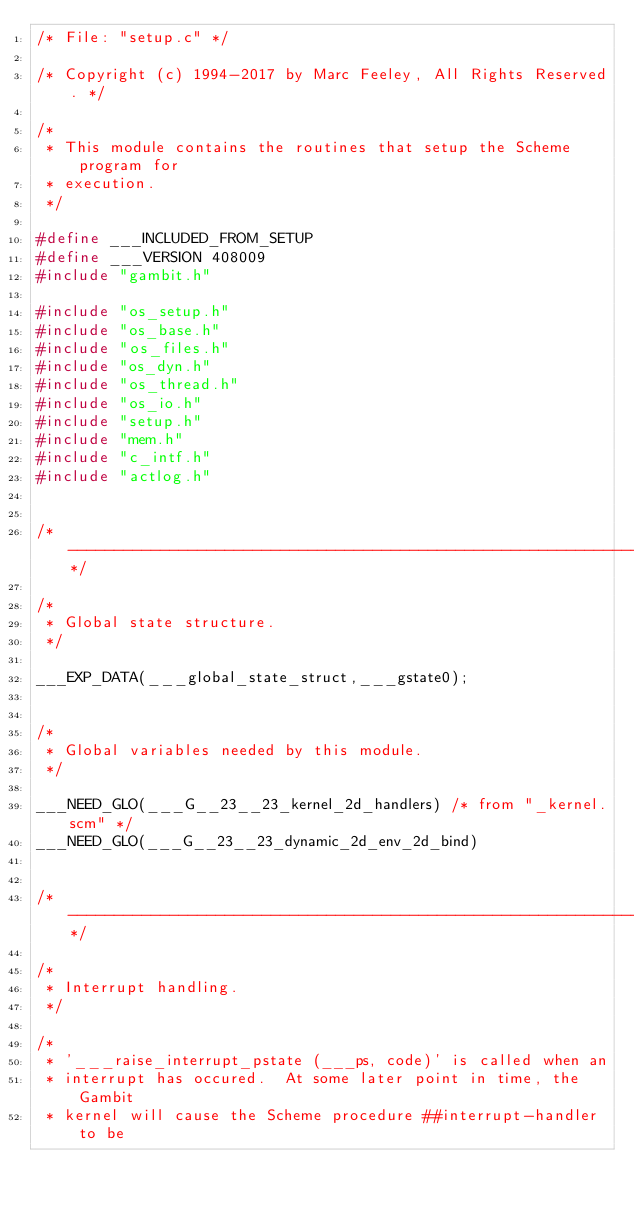<code> <loc_0><loc_0><loc_500><loc_500><_C_>/* File: "setup.c" */

/* Copyright (c) 1994-2017 by Marc Feeley, All Rights Reserved. */

/*
 * This module contains the routines that setup the Scheme program for
 * execution.
 */

#define ___INCLUDED_FROM_SETUP
#define ___VERSION 408009
#include "gambit.h"

#include "os_setup.h"
#include "os_base.h"
#include "os_files.h"
#include "os_dyn.h"
#include "os_thread.h"
#include "os_io.h"
#include "setup.h"
#include "mem.h"
#include "c_intf.h"
#include "actlog.h"


/*---------------------------------------------------------------------------*/

/*
 * Global state structure.
 */

___EXP_DATA(___global_state_struct,___gstate0);


/*
 * Global variables needed by this module.
 */

___NEED_GLO(___G__23__23_kernel_2d_handlers) /* from "_kernel.scm" */
___NEED_GLO(___G__23__23_dynamic_2d_env_2d_bind)


/*---------------------------------------------------------------------------*/

/*
 * Interrupt handling.
 */

/*
 * '___raise_interrupt_pstate (___ps, code)' is called when an
 * interrupt has occured.  At some later point in time, the Gambit
 * kernel will cause the Scheme procedure ##interrupt-handler to be</code> 